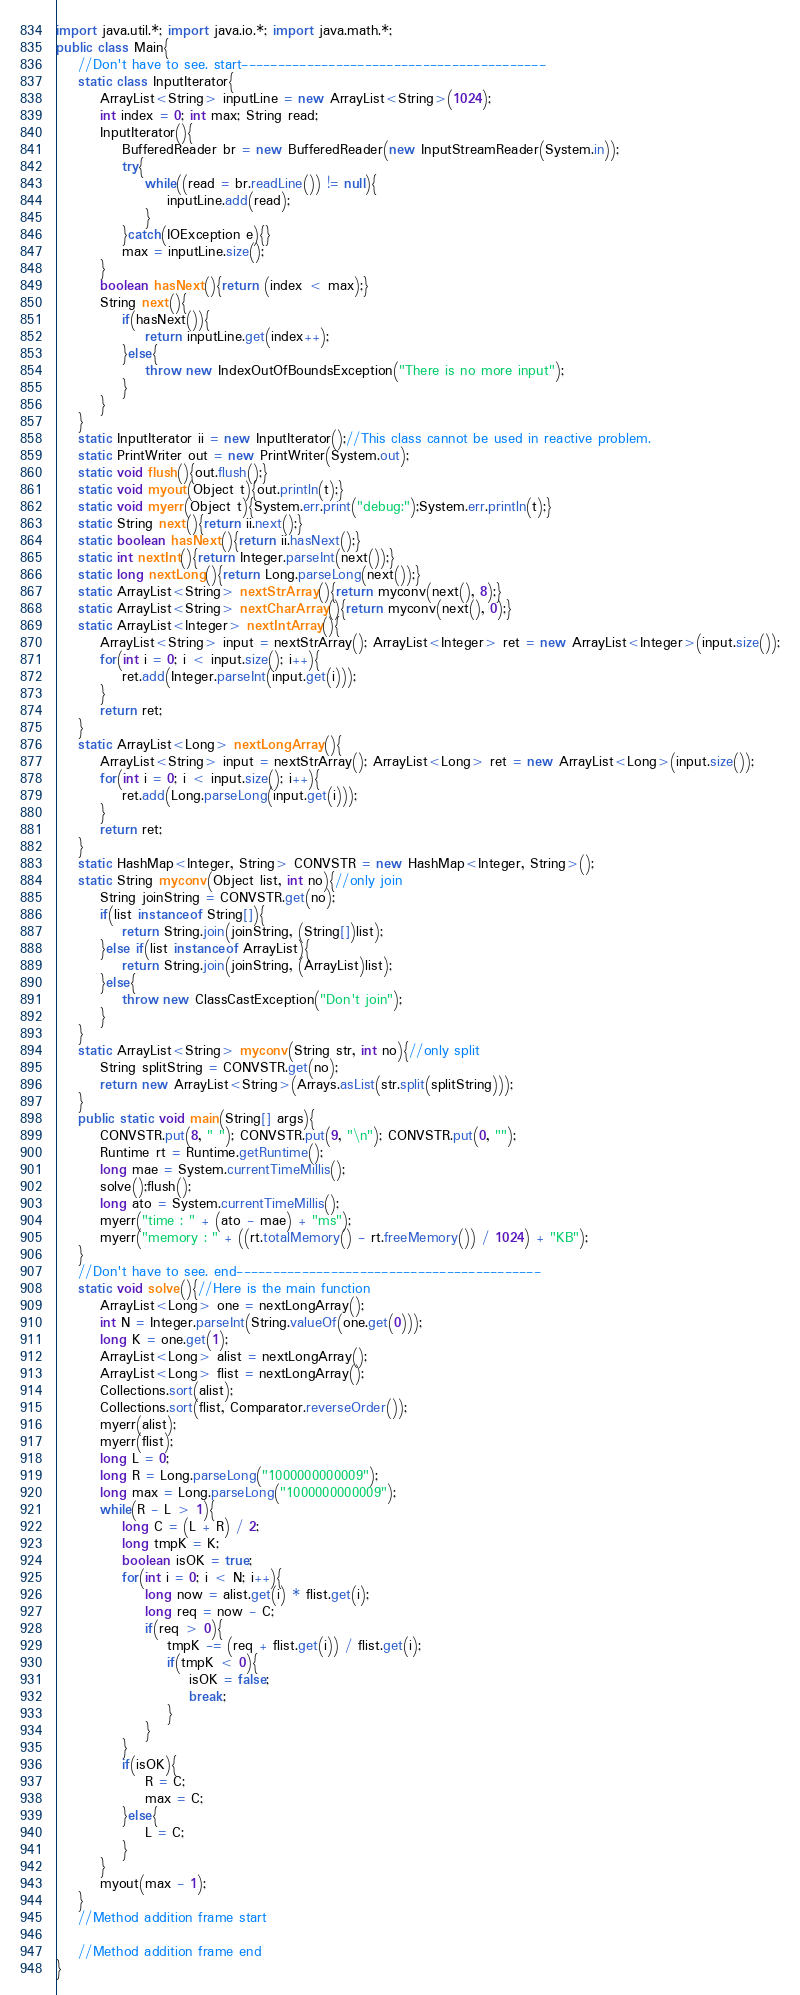Convert code to text. <code><loc_0><loc_0><loc_500><loc_500><_Java_>import java.util.*; import java.io.*; import java.math.*;
public class Main{
	//Don't have to see. start------------------------------------------
	static class InputIterator{
		ArrayList<String> inputLine = new ArrayList<String>(1024);
		int index = 0; int max; String read;
		InputIterator(){
			BufferedReader br = new BufferedReader(new InputStreamReader(System.in));
			try{
				while((read = br.readLine()) != null){
					inputLine.add(read);
				}
			}catch(IOException e){}
			max = inputLine.size();
		}
		boolean hasNext(){return (index < max);}
		String next(){
			if(hasNext()){
				return inputLine.get(index++);
			}else{
				throw new IndexOutOfBoundsException("There is no more input");
			}
		}
	}
	static InputIterator ii = new InputIterator();//This class cannot be used in reactive problem.
	static PrintWriter out = new PrintWriter(System.out);
	static void flush(){out.flush();}
	static void myout(Object t){out.println(t);}
	static void myerr(Object t){System.err.print("debug:");System.err.println(t);}
	static String next(){return ii.next();}
	static boolean hasNext(){return ii.hasNext();}
	static int nextInt(){return Integer.parseInt(next());}
	static long nextLong(){return Long.parseLong(next());}
	static ArrayList<String> nextStrArray(){return myconv(next(), 8);}
	static ArrayList<String> nextCharArray(){return myconv(next(), 0);}
	static ArrayList<Integer> nextIntArray(){
		ArrayList<String> input = nextStrArray(); ArrayList<Integer> ret = new ArrayList<Integer>(input.size());
		for(int i = 0; i < input.size(); i++){
			ret.add(Integer.parseInt(input.get(i)));
		}
		return ret;
	}
	static ArrayList<Long> nextLongArray(){
		ArrayList<String> input = nextStrArray(); ArrayList<Long> ret = new ArrayList<Long>(input.size());
		for(int i = 0; i < input.size(); i++){
			ret.add(Long.parseLong(input.get(i)));
		}
		return ret;
	}
	static HashMap<Integer, String> CONVSTR = new HashMap<Integer, String>();
	static String myconv(Object list, int no){//only join
		String joinString = CONVSTR.get(no);
		if(list instanceof String[]){
			return String.join(joinString, (String[])list);
		}else if(list instanceof ArrayList){
			return String.join(joinString, (ArrayList)list);
		}else{
			throw new ClassCastException("Don't join");
		}
	}
	static ArrayList<String> myconv(String str, int no){//only split
		String splitString = CONVSTR.get(no);
		return new ArrayList<String>(Arrays.asList(str.split(splitString)));
	}
	public static void main(String[] args){
		CONVSTR.put(8, " "); CONVSTR.put(9, "\n"); CONVSTR.put(0, "");
		Runtime rt = Runtime.getRuntime();
		long mae = System.currentTimeMillis();
		solve();flush();
		long ato = System.currentTimeMillis();
		myerr("time : " + (ato - mae) + "ms");
		myerr("memory : " + ((rt.totalMemory() - rt.freeMemory()) / 1024) + "KB");
	}
	//Don't have to see. end------------------------------------------
	static void solve(){//Here is the main function
		ArrayList<Long> one = nextLongArray();
		int N = Integer.parseInt(String.valueOf(one.get(0)));
		long K = one.get(1);
		ArrayList<Long> alist = nextLongArray();
		ArrayList<Long> flist = nextLongArray();
		Collections.sort(alist);
		Collections.sort(flist, Comparator.reverseOrder());
		myerr(alist);
		myerr(flist);
		long L = 0;
		long R = Long.parseLong("1000000000009");
		long max = Long.parseLong("1000000000009");
		while(R - L > 1){
			long C = (L + R) / 2;
			long tmpK = K;
			boolean isOK = true;
			for(int i = 0; i < N; i++){
				long now = alist.get(i) * flist.get(i);
				long req = now - C;
				if(req > 0){
					tmpK -= (req + flist.get(i)) / flist.get(i);
					if(tmpK < 0){
						isOK = false;
						break;
					}
				}
			}
			if(isOK){
				R = C;
				max = C;
			}else{
				L = C;
			}
		}
		myout(max - 1);
	}
	//Method addition frame start

	//Method addition frame end
}
</code> 